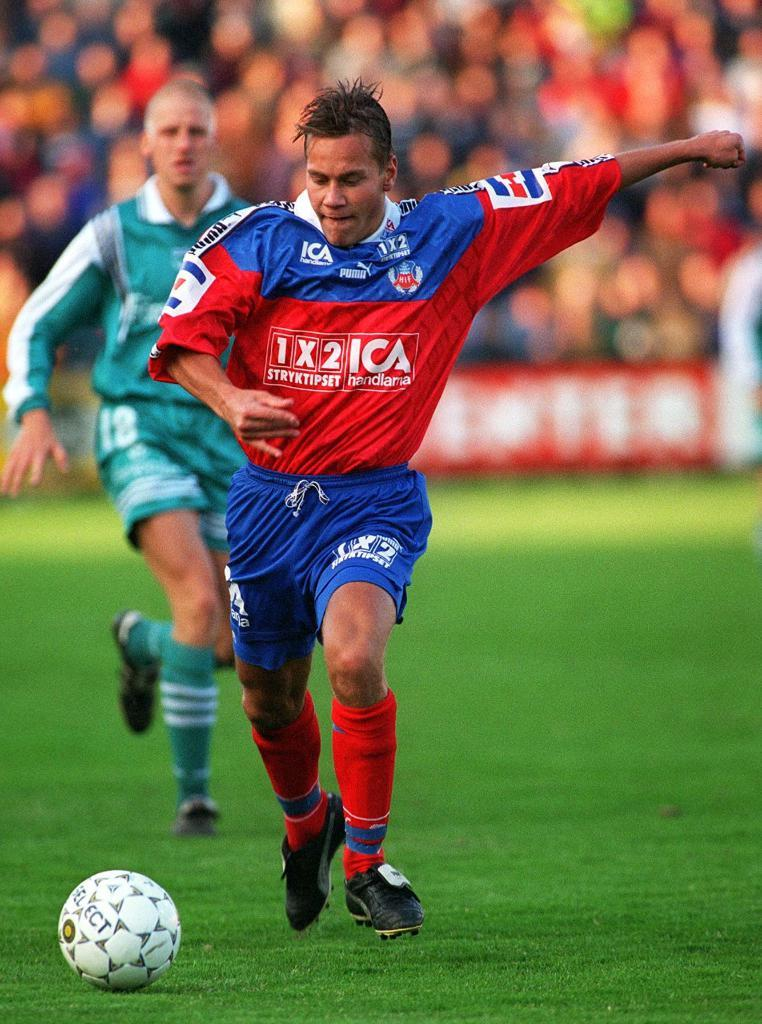<image>
Summarize the visual content of the image. A man in a red and blue ICA soccer uniform runs up to kick a ball. 